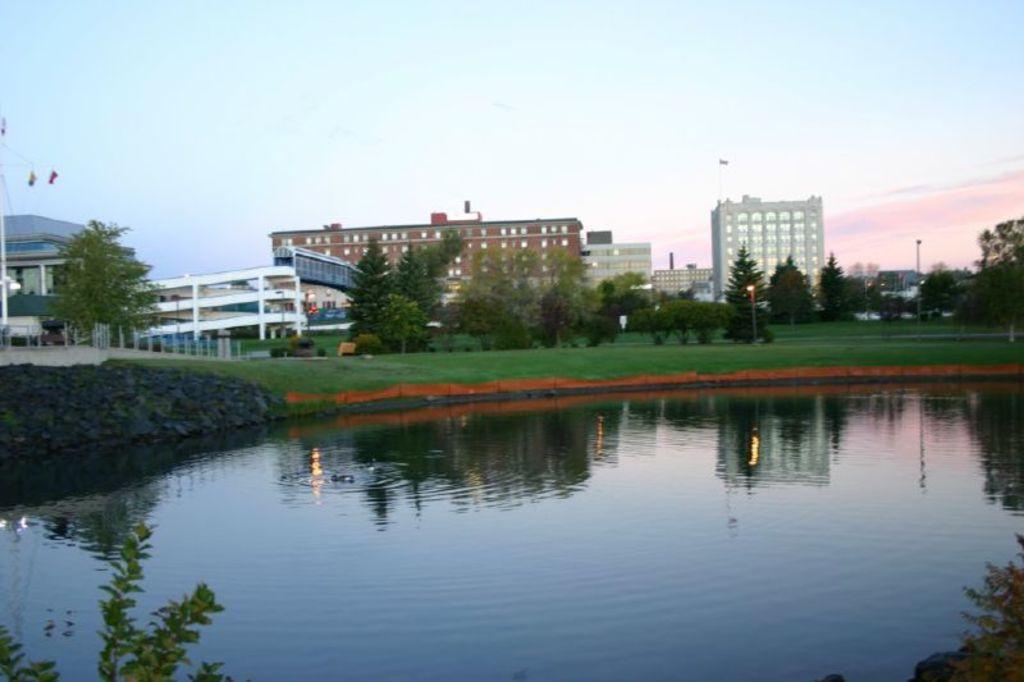Can you describe this image briefly? In this image we can see a lake, grassy land, trees, poles and buildings. The sky is in blue color with some clouds. We can see the leaves in the left and right bottom of the image. 